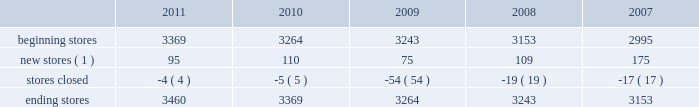The table sets forth information concerning increases in the total number of our aap stores during the past five years : beginning stores new stores ( 1 ) stores closed ending stores ( 1 ) does not include stores that opened as relocations of previously existing stores within the same general market area or substantial renovations of stores .
Our store-based information systems , which are designed to improve the efficiency of our operations and enhance customer service , are comprised of a proprietary pos system and electronic parts catalog , or epc , system .
Information maintained by our pos system is used to formulate pricing , marketing and merchandising strategies and to replenish inventory accurately and rapidly .
Our pos system is fully integrated with our epc system and enables our store team members to assist our customers in their parts selection and ordering based on the year , make , model and engine type of their vehicles .
Our centrally-based epc data management system enables us to reduce the time needed to ( i ) exchange data with our vendors and ( ii ) catalog and deliver updated , accurate parts information .
Our epc system also contains enhanced search engines and user-friendly navigation tools that enhance our team members' ability to look up any needed parts as well as additional products the customer needs to complete an automotive repair project .
If a hard-to-find part or accessory is not available at one of our stores , the epc system can determine whether the part is carried and in-stock through our hub or pdq ae networks or can be ordered directly from one of our vendors .
Available parts and accessories are then ordered electronically from another store , hub , pdq ae or directly from the vendor with immediate confirmation of price , availability and estimated delivery time .
We also support our store operations with additional proprietary systems and customer driven labor scheduling capabilities .
Our store-level inventory management system provides real-time inventory tracking at the store level .
With the store-level system , store team members can check the quantity of on-hand inventory for any sku , adjust stock levels for select items for store specific events , automatically process returns and defective merchandise , designate skus for cycle counts and track merchandise transfers .
Our stores use radio frequency hand-held devices to help ensure the accuracy of our inventory .
Our standard operating procedure , or sop , system is a web-based , electronic data management system that provides our team members with instant access to any of our standard operating procedures through a comprehensive on-line search function .
All of these systems are tightly integrated and provide real-time , comprehensive information to store personnel , resulting in improved customer service levels , team member productivity and in-stock availability .
Purchasing for virtually all of the merchandise for our stores is handled by our merchandise teams located in three primary locations : 2022 store support center in roanoke , virginia ; 2022 regional office in minneapolis , minnesota ; and 2022 global sourcing office in taipei , taiwan .
Our roanoke team is primarily responsible for the parts categories and our minnesota team is primarily responsible for accessories , oil and chemicals .
Our global sourcing team works closely with both teams .
In fiscal 2011 , we purchased merchandise from approximately 500 vendors , with no single vendor accounting for more than 9% ( 9 % ) of purchases .
Our purchasing strategy involves negotiating agreements with most of our vendors to purchase merchandise over a specified period of time along with other terms , including pricing , payment terms and volume .
The merchandising team has developed strong vendor relationships in the industry and , in a collaborative effort with our vendor partners , utilizes a category management process where we manage the mix of our product offerings to meet customer demand .
We believe this process , which develops a customer-focused business plan for each merchandise category , and our global sourcing operation are critical to improving comparable store sales , gross margin and inventory productivity. .
The following table sets forth information concerning increases in the total number of our aap stores during the past five years : beginning stores new stores ( 1 ) stores closed ending stores ( 1 ) does not include stores that opened as relocations of previously existing stores within the same general market area or substantial renovations of stores .
Our store-based information systems , which are designed to improve the efficiency of our operations and enhance customer service , are comprised of a proprietary pos system and electronic parts catalog , or epc , system .
Information maintained by our pos system is used to formulate pricing , marketing and merchandising strategies and to replenish inventory accurately and rapidly .
Our pos system is fully integrated with our epc system and enables our store team members to assist our customers in their parts selection and ordering based on the year , make , model and engine type of their vehicles .
Our centrally-based epc data management system enables us to reduce the time needed to ( i ) exchange data with our vendors and ( ii ) catalog and deliver updated , accurate parts information .
Our epc system also contains enhanced search engines and user-friendly navigation tools that enhance our team members' ability to look up any needed parts as well as additional products the customer needs to complete an automotive repair project .
If a hard-to-find part or accessory is not available at one of our stores , the epc system can determine whether the part is carried and in-stock through our hub or pdq ae networks or can be ordered directly from one of our vendors .
Available parts and accessories are then ordered electronically from another store , hub , pdq ae or directly from the vendor with immediate confirmation of price , availability and estimated delivery time .
We also support our store operations with additional proprietary systems and customer driven labor scheduling capabilities .
Our store-level inventory management system provides real-time inventory tracking at the store level .
With the store-level system , store team members can check the quantity of on-hand inventory for any sku , adjust stock levels for select items for store specific events , automatically process returns and defective merchandise , designate skus for cycle counts and track merchandise transfers .
Our stores use radio frequency hand-held devices to help ensure the accuracy of our inventory .
Our standard operating procedure , or sop , system is a web-based , electronic data management system that provides our team members with instant access to any of our standard operating procedures through a comprehensive on-line search function .
All of these systems are tightly integrated and provide real-time , comprehensive information to store personnel , resulting in improved customer service levels , team member productivity and in-stock availability .
Purchasing for virtually all of the merchandise for our stores is handled by our merchandise teams located in three primary locations : 2022 store support center in roanoke , virginia ; 2022 regional office in minneapolis , minnesota ; and 2022 global sourcing office in taipei , taiwan .
Our roanoke team is primarily responsible for the parts categories and our minnesota team is primarily responsible for accessories , oil and chemicals .
Our global sourcing team works closely with both teams .
In fiscal 2011 , we purchased merchandise from approximately 500 vendors , with no single vendor accounting for more than 9% ( 9 % ) of purchases .
Our purchasing strategy involves negotiating agreements with most of our vendors to purchase merchandise over a specified period of time along with other terms , including pricing , payment terms and volume .
The merchandising team has developed strong vendor relationships in the industry and , in a collaborative effort with our vendor partners , utilizes a category management process where we manage the mix of our product offerings to meet customer demand .
We believe this process , which develops a customer-focused business plan for each merchandise category , and our global sourcing operation are critical to improving comparable store sales , gross margin and inventory productivity. .
What is the net number of stores that opened during 2011? 
Computations: (95 - 4)
Answer: 91.0. 